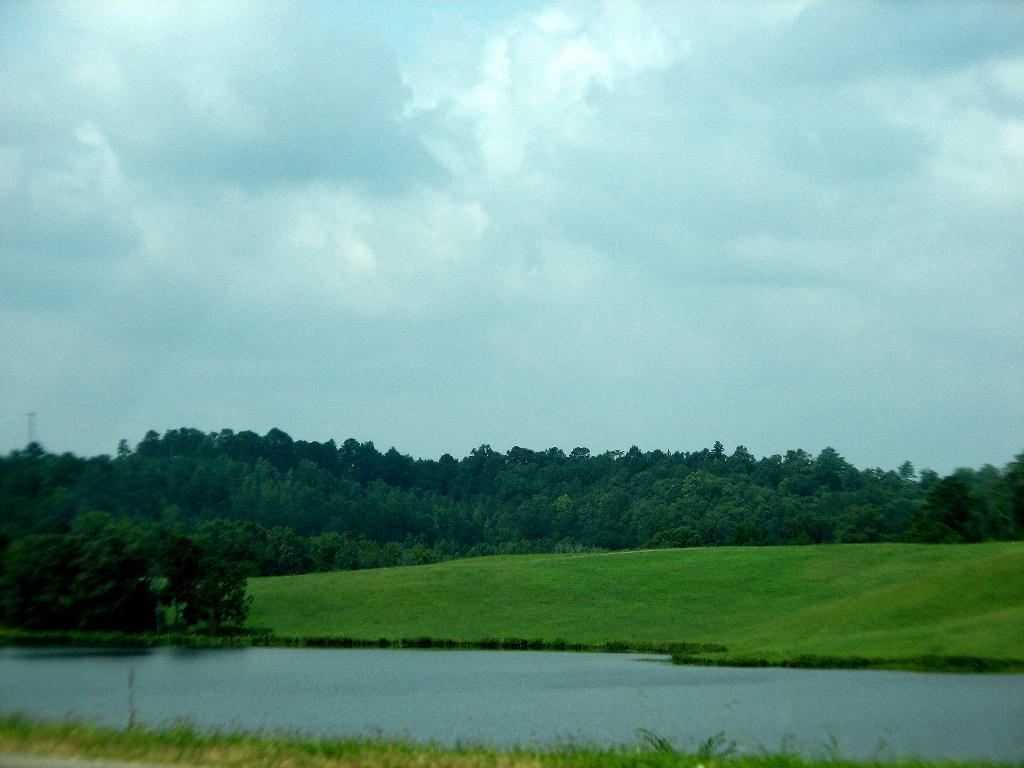Can you describe this image briefly? In this picture we can see grass on the ground. We can see water, plants, trees and the cloudy sky. 